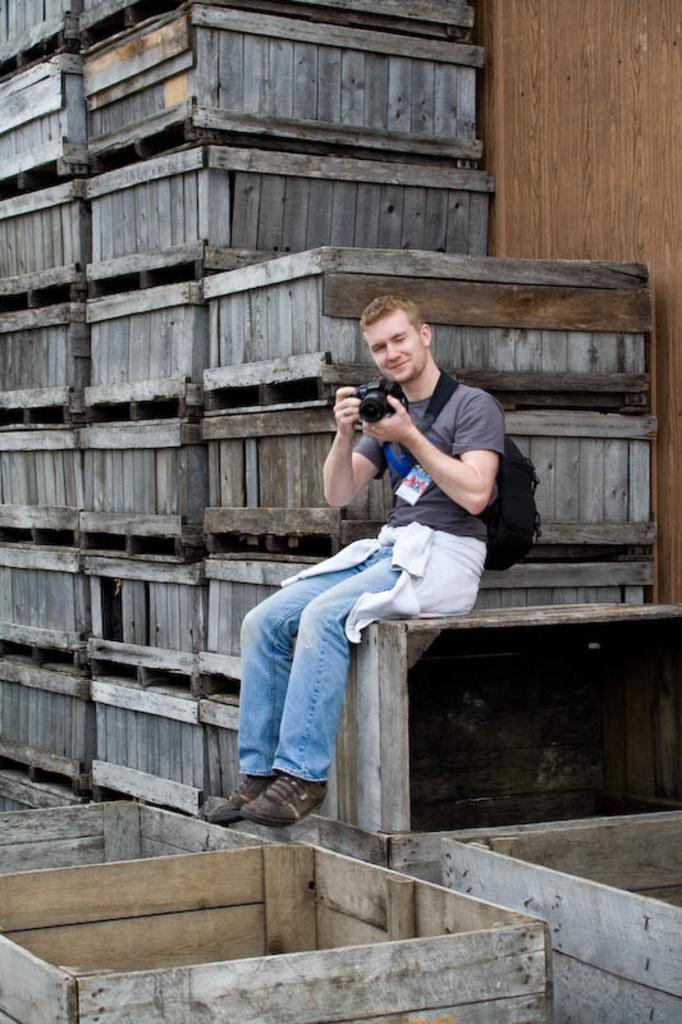How would you summarize this image in a sentence or two? Here we can see a person sitting, and holding a camera in his hands, and at side there are wooden boxes. 